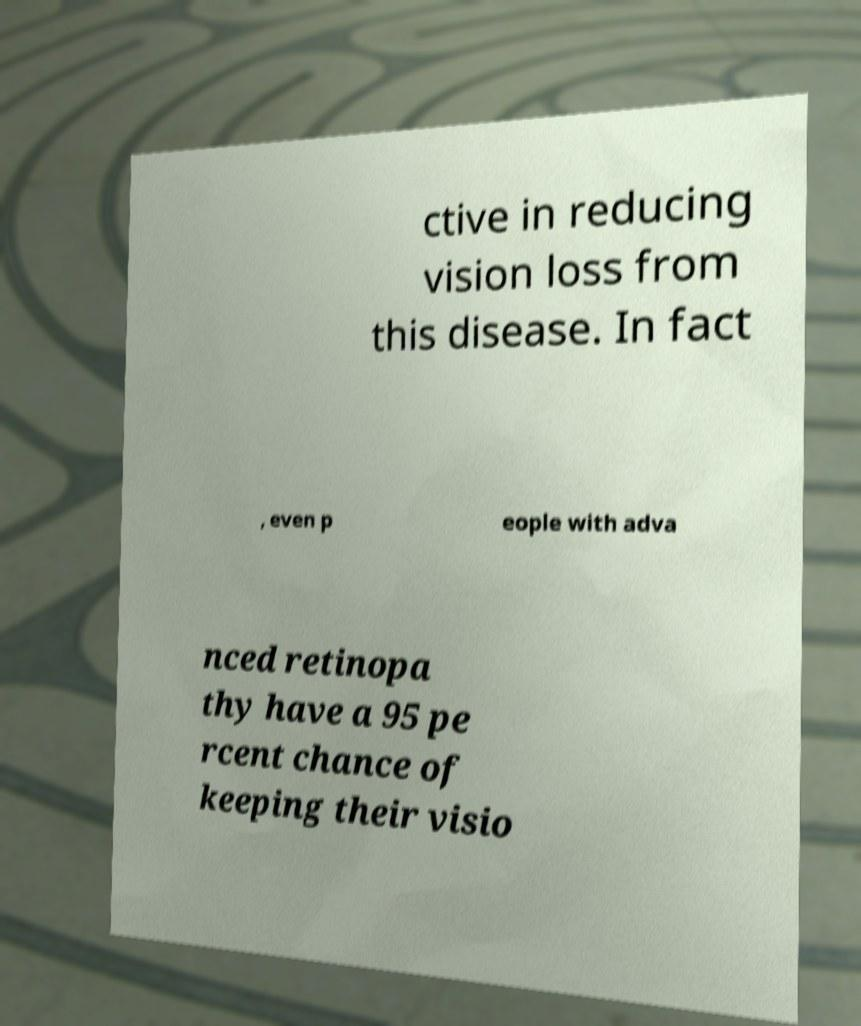There's text embedded in this image that I need extracted. Can you transcribe it verbatim? ctive in reducing vision loss from this disease. In fact , even p eople with adva nced retinopa thy have a 95 pe rcent chance of keeping their visio 